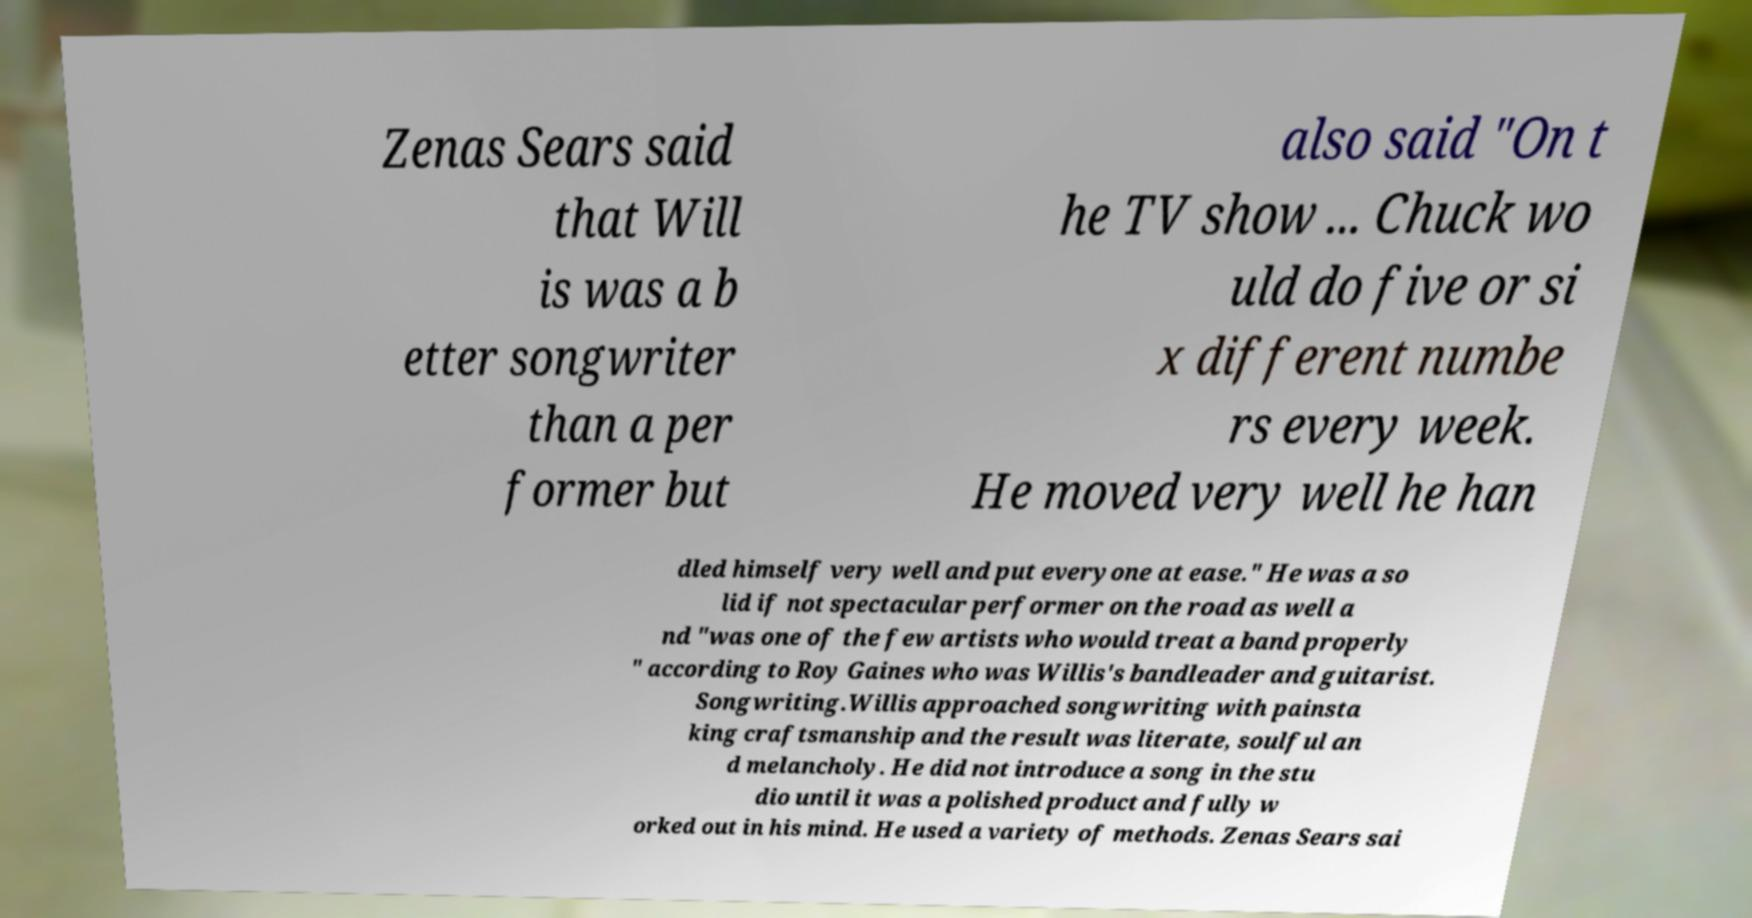What messages or text are displayed in this image? I need them in a readable, typed format. Zenas Sears said that Will is was a b etter songwriter than a per former but also said "On t he TV show ... Chuck wo uld do five or si x different numbe rs every week. He moved very well he han dled himself very well and put everyone at ease." He was a so lid if not spectacular performer on the road as well a nd "was one of the few artists who would treat a band properly " according to Roy Gaines who was Willis's bandleader and guitarist. Songwriting.Willis approached songwriting with painsta king craftsmanship and the result was literate, soulful an d melancholy. He did not introduce a song in the stu dio until it was a polished product and fully w orked out in his mind. He used a variety of methods. Zenas Sears sai 